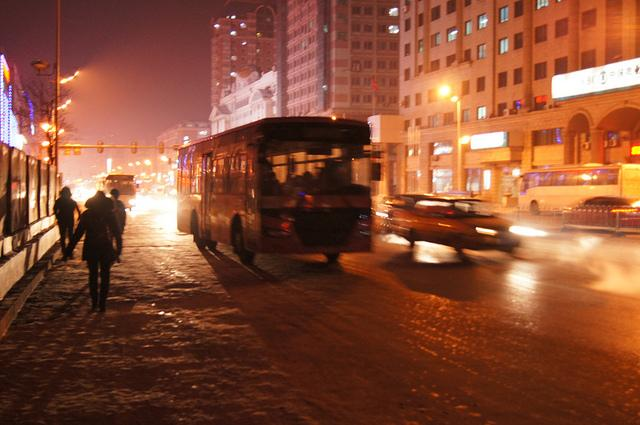What hazard appears to be occurring on the road?

Choices:
A) too hot
B) too cold
C) water
D) slippery slippery 